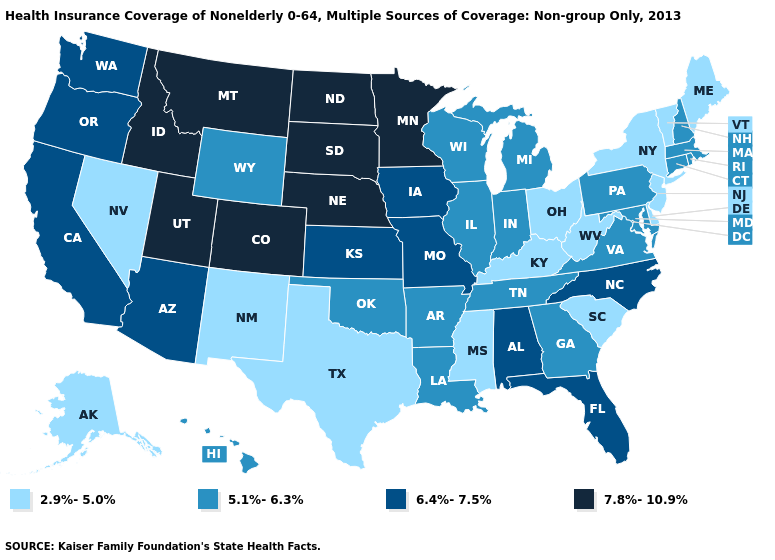Name the states that have a value in the range 5.1%-6.3%?
Keep it brief. Arkansas, Connecticut, Georgia, Hawaii, Illinois, Indiana, Louisiana, Maryland, Massachusetts, Michigan, New Hampshire, Oklahoma, Pennsylvania, Rhode Island, Tennessee, Virginia, Wisconsin, Wyoming. Name the states that have a value in the range 2.9%-5.0%?
Be succinct. Alaska, Delaware, Kentucky, Maine, Mississippi, Nevada, New Jersey, New Mexico, New York, Ohio, South Carolina, Texas, Vermont, West Virginia. What is the value of Indiana?
Concise answer only. 5.1%-6.3%. What is the value of Michigan?
Keep it brief. 5.1%-6.3%. Name the states that have a value in the range 5.1%-6.3%?
Write a very short answer. Arkansas, Connecticut, Georgia, Hawaii, Illinois, Indiana, Louisiana, Maryland, Massachusetts, Michigan, New Hampshire, Oklahoma, Pennsylvania, Rhode Island, Tennessee, Virginia, Wisconsin, Wyoming. Among the states that border Ohio , does West Virginia have the lowest value?
Quick response, please. Yes. Name the states that have a value in the range 2.9%-5.0%?
Concise answer only. Alaska, Delaware, Kentucky, Maine, Mississippi, Nevada, New Jersey, New Mexico, New York, Ohio, South Carolina, Texas, Vermont, West Virginia. Which states hav the highest value in the Northeast?
Answer briefly. Connecticut, Massachusetts, New Hampshire, Pennsylvania, Rhode Island. What is the value of Missouri?
Be succinct. 6.4%-7.5%. Name the states that have a value in the range 5.1%-6.3%?
Write a very short answer. Arkansas, Connecticut, Georgia, Hawaii, Illinois, Indiana, Louisiana, Maryland, Massachusetts, Michigan, New Hampshire, Oklahoma, Pennsylvania, Rhode Island, Tennessee, Virginia, Wisconsin, Wyoming. What is the highest value in states that border Alabama?
Be succinct. 6.4%-7.5%. Does Oregon have the highest value in the West?
Quick response, please. No. Name the states that have a value in the range 2.9%-5.0%?
Give a very brief answer. Alaska, Delaware, Kentucky, Maine, Mississippi, Nevada, New Jersey, New Mexico, New York, Ohio, South Carolina, Texas, Vermont, West Virginia. What is the lowest value in the West?
Short answer required. 2.9%-5.0%. 